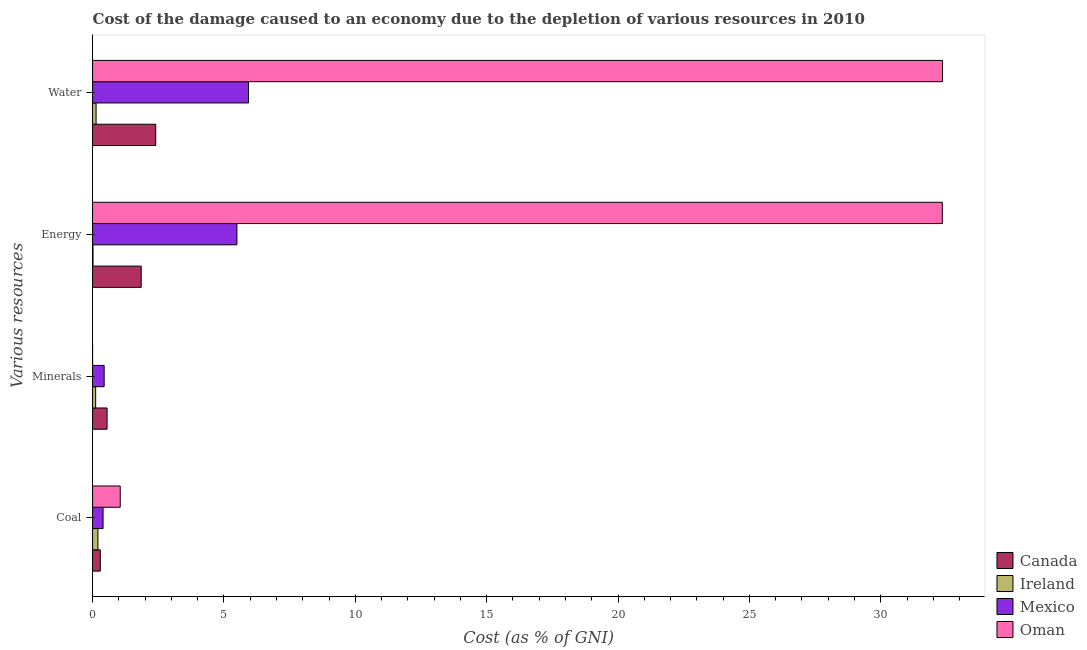How many different coloured bars are there?
Provide a succinct answer. 4. How many bars are there on the 4th tick from the bottom?
Offer a very short reply. 4. What is the label of the 3rd group of bars from the top?
Give a very brief answer. Minerals. What is the cost of damage due to depletion of coal in Ireland?
Your answer should be compact. 0.2. Across all countries, what is the maximum cost of damage due to depletion of coal?
Your answer should be very brief. 1.05. Across all countries, what is the minimum cost of damage due to depletion of minerals?
Make the answer very short. 0. In which country was the cost of damage due to depletion of coal maximum?
Provide a short and direct response. Oman. In which country was the cost of damage due to depletion of coal minimum?
Provide a short and direct response. Ireland. What is the total cost of damage due to depletion of minerals in the graph?
Make the answer very short. 1.11. What is the difference between the cost of damage due to depletion of coal in Canada and that in Mexico?
Offer a terse response. -0.1. What is the difference between the cost of damage due to depletion of energy in Oman and the cost of damage due to depletion of minerals in Ireland?
Your answer should be very brief. 32.22. What is the average cost of damage due to depletion of coal per country?
Your response must be concise. 0.49. What is the difference between the cost of damage due to depletion of water and cost of damage due to depletion of minerals in Ireland?
Your answer should be compact. 0.02. What is the ratio of the cost of damage due to depletion of minerals in Ireland to that in Oman?
Your answer should be very brief. 238.04. What is the difference between the highest and the second highest cost of damage due to depletion of water?
Offer a very short reply. 26.41. What is the difference between the highest and the lowest cost of damage due to depletion of minerals?
Your response must be concise. 0.55. In how many countries, is the cost of damage due to depletion of water greater than the average cost of damage due to depletion of water taken over all countries?
Ensure brevity in your answer.  1. Is the sum of the cost of damage due to depletion of coal in Ireland and Canada greater than the maximum cost of damage due to depletion of energy across all countries?
Provide a short and direct response. No. Is it the case that in every country, the sum of the cost of damage due to depletion of coal and cost of damage due to depletion of minerals is greater than the sum of cost of damage due to depletion of water and cost of damage due to depletion of energy?
Your answer should be compact. No. What does the 4th bar from the top in Energy represents?
Provide a short and direct response. Canada. How many countries are there in the graph?
Keep it short and to the point. 4. What is the difference between two consecutive major ticks on the X-axis?
Your response must be concise. 5. Are the values on the major ticks of X-axis written in scientific E-notation?
Keep it short and to the point. No. Does the graph contain any zero values?
Ensure brevity in your answer.  No. Where does the legend appear in the graph?
Your answer should be very brief. Bottom right. What is the title of the graph?
Your answer should be compact. Cost of the damage caused to an economy due to the depletion of various resources in 2010 . What is the label or title of the X-axis?
Provide a succinct answer. Cost (as % of GNI). What is the label or title of the Y-axis?
Make the answer very short. Various resources. What is the Cost (as % of GNI) in Canada in Coal?
Offer a terse response. 0.29. What is the Cost (as % of GNI) of Ireland in Coal?
Give a very brief answer. 0.2. What is the Cost (as % of GNI) in Mexico in Coal?
Keep it short and to the point. 0.4. What is the Cost (as % of GNI) of Oman in Coal?
Keep it short and to the point. 1.05. What is the Cost (as % of GNI) in Canada in Minerals?
Ensure brevity in your answer.  0.55. What is the Cost (as % of GNI) in Ireland in Minerals?
Ensure brevity in your answer.  0.12. What is the Cost (as % of GNI) of Mexico in Minerals?
Make the answer very short. 0.44. What is the Cost (as % of GNI) in Oman in Minerals?
Provide a succinct answer. 0. What is the Cost (as % of GNI) of Canada in Energy?
Your answer should be very brief. 1.85. What is the Cost (as % of GNI) of Ireland in Energy?
Ensure brevity in your answer.  0.02. What is the Cost (as % of GNI) in Mexico in Energy?
Make the answer very short. 5.49. What is the Cost (as % of GNI) of Oman in Energy?
Provide a succinct answer. 32.34. What is the Cost (as % of GNI) of Canada in Water?
Keep it short and to the point. 2.4. What is the Cost (as % of GNI) in Ireland in Water?
Provide a succinct answer. 0.13. What is the Cost (as % of GNI) in Mexico in Water?
Offer a terse response. 5.93. What is the Cost (as % of GNI) in Oman in Water?
Make the answer very short. 32.35. Across all Various resources, what is the maximum Cost (as % of GNI) of Canada?
Make the answer very short. 2.4. Across all Various resources, what is the maximum Cost (as % of GNI) in Ireland?
Provide a succinct answer. 0.2. Across all Various resources, what is the maximum Cost (as % of GNI) of Mexico?
Provide a succinct answer. 5.93. Across all Various resources, what is the maximum Cost (as % of GNI) in Oman?
Your answer should be very brief. 32.35. Across all Various resources, what is the minimum Cost (as % of GNI) of Canada?
Give a very brief answer. 0.29. Across all Various resources, what is the minimum Cost (as % of GNI) in Ireland?
Offer a terse response. 0.02. Across all Various resources, what is the minimum Cost (as % of GNI) of Mexico?
Your answer should be compact. 0.4. Across all Various resources, what is the minimum Cost (as % of GNI) of Oman?
Your answer should be compact. 0. What is the total Cost (as % of GNI) of Canada in the graph?
Ensure brevity in your answer.  5.1. What is the total Cost (as % of GNI) of Ireland in the graph?
Make the answer very short. 0.47. What is the total Cost (as % of GNI) in Mexico in the graph?
Offer a very short reply. 12.27. What is the total Cost (as % of GNI) of Oman in the graph?
Offer a very short reply. 65.74. What is the difference between the Cost (as % of GNI) in Canada in Coal and that in Minerals?
Make the answer very short. -0.26. What is the difference between the Cost (as % of GNI) in Ireland in Coal and that in Minerals?
Your response must be concise. 0.09. What is the difference between the Cost (as % of GNI) of Mexico in Coal and that in Minerals?
Your response must be concise. -0.04. What is the difference between the Cost (as % of GNI) in Oman in Coal and that in Minerals?
Offer a terse response. 1.05. What is the difference between the Cost (as % of GNI) in Canada in Coal and that in Energy?
Offer a terse response. -1.56. What is the difference between the Cost (as % of GNI) in Ireland in Coal and that in Energy?
Offer a terse response. 0.19. What is the difference between the Cost (as % of GNI) in Mexico in Coal and that in Energy?
Ensure brevity in your answer.  -5.09. What is the difference between the Cost (as % of GNI) in Oman in Coal and that in Energy?
Your answer should be very brief. -31.29. What is the difference between the Cost (as % of GNI) of Canada in Coal and that in Water?
Provide a short and direct response. -2.11. What is the difference between the Cost (as % of GNI) in Ireland in Coal and that in Water?
Keep it short and to the point. 0.07. What is the difference between the Cost (as % of GNI) in Mexico in Coal and that in Water?
Your answer should be compact. -5.54. What is the difference between the Cost (as % of GNI) in Oman in Coal and that in Water?
Provide a short and direct response. -31.29. What is the difference between the Cost (as % of GNI) of Canada in Minerals and that in Energy?
Keep it short and to the point. -1.3. What is the difference between the Cost (as % of GNI) of Ireland in Minerals and that in Energy?
Give a very brief answer. 0.1. What is the difference between the Cost (as % of GNI) in Mexico in Minerals and that in Energy?
Provide a succinct answer. -5.05. What is the difference between the Cost (as % of GNI) in Oman in Minerals and that in Energy?
Make the answer very short. -32.34. What is the difference between the Cost (as % of GNI) in Canada in Minerals and that in Water?
Your response must be concise. -1.85. What is the difference between the Cost (as % of GNI) in Ireland in Minerals and that in Water?
Your answer should be compact. -0.02. What is the difference between the Cost (as % of GNI) of Mexico in Minerals and that in Water?
Provide a short and direct response. -5.49. What is the difference between the Cost (as % of GNI) in Oman in Minerals and that in Water?
Give a very brief answer. -32.35. What is the difference between the Cost (as % of GNI) of Canada in Energy and that in Water?
Provide a short and direct response. -0.55. What is the difference between the Cost (as % of GNI) in Ireland in Energy and that in Water?
Make the answer very short. -0.12. What is the difference between the Cost (as % of GNI) of Mexico in Energy and that in Water?
Provide a succinct answer. -0.44. What is the difference between the Cost (as % of GNI) of Oman in Energy and that in Water?
Your response must be concise. -0.01. What is the difference between the Cost (as % of GNI) of Canada in Coal and the Cost (as % of GNI) of Ireland in Minerals?
Your response must be concise. 0.18. What is the difference between the Cost (as % of GNI) in Canada in Coal and the Cost (as % of GNI) in Mexico in Minerals?
Provide a short and direct response. -0.15. What is the difference between the Cost (as % of GNI) of Canada in Coal and the Cost (as % of GNI) of Oman in Minerals?
Offer a very short reply. 0.29. What is the difference between the Cost (as % of GNI) of Ireland in Coal and the Cost (as % of GNI) of Mexico in Minerals?
Offer a terse response. -0.24. What is the difference between the Cost (as % of GNI) in Ireland in Coal and the Cost (as % of GNI) in Oman in Minerals?
Your answer should be very brief. 0.2. What is the difference between the Cost (as % of GNI) in Mexico in Coal and the Cost (as % of GNI) in Oman in Minerals?
Your answer should be compact. 0.4. What is the difference between the Cost (as % of GNI) of Canada in Coal and the Cost (as % of GNI) of Ireland in Energy?
Ensure brevity in your answer.  0.28. What is the difference between the Cost (as % of GNI) in Canada in Coal and the Cost (as % of GNI) in Mexico in Energy?
Give a very brief answer. -5.2. What is the difference between the Cost (as % of GNI) of Canada in Coal and the Cost (as % of GNI) of Oman in Energy?
Provide a short and direct response. -32.05. What is the difference between the Cost (as % of GNI) of Ireland in Coal and the Cost (as % of GNI) of Mexico in Energy?
Ensure brevity in your answer.  -5.29. What is the difference between the Cost (as % of GNI) of Ireland in Coal and the Cost (as % of GNI) of Oman in Energy?
Provide a succinct answer. -32.14. What is the difference between the Cost (as % of GNI) of Mexico in Coal and the Cost (as % of GNI) of Oman in Energy?
Provide a succinct answer. -31.94. What is the difference between the Cost (as % of GNI) in Canada in Coal and the Cost (as % of GNI) in Ireland in Water?
Offer a terse response. 0.16. What is the difference between the Cost (as % of GNI) in Canada in Coal and the Cost (as % of GNI) in Mexico in Water?
Make the answer very short. -5.64. What is the difference between the Cost (as % of GNI) in Canada in Coal and the Cost (as % of GNI) in Oman in Water?
Keep it short and to the point. -32.05. What is the difference between the Cost (as % of GNI) of Ireland in Coal and the Cost (as % of GNI) of Mexico in Water?
Provide a succinct answer. -5.73. What is the difference between the Cost (as % of GNI) of Ireland in Coal and the Cost (as % of GNI) of Oman in Water?
Provide a short and direct response. -32.14. What is the difference between the Cost (as % of GNI) in Mexico in Coal and the Cost (as % of GNI) in Oman in Water?
Provide a succinct answer. -31.95. What is the difference between the Cost (as % of GNI) in Canada in Minerals and the Cost (as % of GNI) in Ireland in Energy?
Make the answer very short. 0.54. What is the difference between the Cost (as % of GNI) in Canada in Minerals and the Cost (as % of GNI) in Mexico in Energy?
Offer a terse response. -4.94. What is the difference between the Cost (as % of GNI) of Canada in Minerals and the Cost (as % of GNI) of Oman in Energy?
Your answer should be compact. -31.79. What is the difference between the Cost (as % of GNI) in Ireland in Minerals and the Cost (as % of GNI) in Mexico in Energy?
Ensure brevity in your answer.  -5.38. What is the difference between the Cost (as % of GNI) in Ireland in Minerals and the Cost (as % of GNI) in Oman in Energy?
Offer a very short reply. -32.22. What is the difference between the Cost (as % of GNI) of Mexico in Minerals and the Cost (as % of GNI) of Oman in Energy?
Your answer should be very brief. -31.9. What is the difference between the Cost (as % of GNI) in Canada in Minerals and the Cost (as % of GNI) in Ireland in Water?
Your answer should be compact. 0.42. What is the difference between the Cost (as % of GNI) in Canada in Minerals and the Cost (as % of GNI) in Mexico in Water?
Offer a terse response. -5.38. What is the difference between the Cost (as % of GNI) of Canada in Minerals and the Cost (as % of GNI) of Oman in Water?
Your answer should be compact. -31.8. What is the difference between the Cost (as % of GNI) of Ireland in Minerals and the Cost (as % of GNI) of Mexico in Water?
Provide a succinct answer. -5.82. What is the difference between the Cost (as % of GNI) of Ireland in Minerals and the Cost (as % of GNI) of Oman in Water?
Keep it short and to the point. -32.23. What is the difference between the Cost (as % of GNI) in Mexico in Minerals and the Cost (as % of GNI) in Oman in Water?
Give a very brief answer. -31.91. What is the difference between the Cost (as % of GNI) in Canada in Energy and the Cost (as % of GNI) in Ireland in Water?
Offer a terse response. 1.72. What is the difference between the Cost (as % of GNI) in Canada in Energy and the Cost (as % of GNI) in Mexico in Water?
Your response must be concise. -4.08. What is the difference between the Cost (as % of GNI) of Canada in Energy and the Cost (as % of GNI) of Oman in Water?
Give a very brief answer. -30.5. What is the difference between the Cost (as % of GNI) of Ireland in Energy and the Cost (as % of GNI) of Mexico in Water?
Offer a very short reply. -5.92. What is the difference between the Cost (as % of GNI) in Ireland in Energy and the Cost (as % of GNI) in Oman in Water?
Keep it short and to the point. -32.33. What is the difference between the Cost (as % of GNI) in Mexico in Energy and the Cost (as % of GNI) in Oman in Water?
Ensure brevity in your answer.  -26.85. What is the average Cost (as % of GNI) in Canada per Various resources?
Give a very brief answer. 1.28. What is the average Cost (as % of GNI) in Ireland per Various resources?
Offer a very short reply. 0.12. What is the average Cost (as % of GNI) in Mexico per Various resources?
Keep it short and to the point. 3.07. What is the average Cost (as % of GNI) in Oman per Various resources?
Provide a succinct answer. 16.44. What is the difference between the Cost (as % of GNI) in Canada and Cost (as % of GNI) in Ireland in Coal?
Your answer should be very brief. 0.09. What is the difference between the Cost (as % of GNI) in Canada and Cost (as % of GNI) in Mexico in Coal?
Offer a terse response. -0.1. What is the difference between the Cost (as % of GNI) of Canada and Cost (as % of GNI) of Oman in Coal?
Offer a very short reply. -0.76. What is the difference between the Cost (as % of GNI) of Ireland and Cost (as % of GNI) of Mexico in Coal?
Your answer should be compact. -0.2. What is the difference between the Cost (as % of GNI) in Ireland and Cost (as % of GNI) in Oman in Coal?
Give a very brief answer. -0.85. What is the difference between the Cost (as % of GNI) of Mexico and Cost (as % of GNI) of Oman in Coal?
Offer a terse response. -0.65. What is the difference between the Cost (as % of GNI) of Canada and Cost (as % of GNI) of Ireland in Minerals?
Offer a terse response. 0.43. What is the difference between the Cost (as % of GNI) of Canada and Cost (as % of GNI) of Mexico in Minerals?
Your answer should be compact. 0.11. What is the difference between the Cost (as % of GNI) in Canada and Cost (as % of GNI) in Oman in Minerals?
Make the answer very short. 0.55. What is the difference between the Cost (as % of GNI) of Ireland and Cost (as % of GNI) of Mexico in Minerals?
Offer a very short reply. -0.32. What is the difference between the Cost (as % of GNI) of Ireland and Cost (as % of GNI) of Oman in Minerals?
Ensure brevity in your answer.  0.12. What is the difference between the Cost (as % of GNI) in Mexico and Cost (as % of GNI) in Oman in Minerals?
Keep it short and to the point. 0.44. What is the difference between the Cost (as % of GNI) in Canada and Cost (as % of GNI) in Ireland in Energy?
Offer a terse response. 1.83. What is the difference between the Cost (as % of GNI) of Canada and Cost (as % of GNI) of Mexico in Energy?
Give a very brief answer. -3.64. What is the difference between the Cost (as % of GNI) in Canada and Cost (as % of GNI) in Oman in Energy?
Ensure brevity in your answer.  -30.49. What is the difference between the Cost (as % of GNI) of Ireland and Cost (as % of GNI) of Mexico in Energy?
Make the answer very short. -5.48. What is the difference between the Cost (as % of GNI) of Ireland and Cost (as % of GNI) of Oman in Energy?
Your response must be concise. -32.33. What is the difference between the Cost (as % of GNI) of Mexico and Cost (as % of GNI) of Oman in Energy?
Provide a short and direct response. -26.85. What is the difference between the Cost (as % of GNI) in Canada and Cost (as % of GNI) in Ireland in Water?
Your response must be concise. 2.27. What is the difference between the Cost (as % of GNI) of Canada and Cost (as % of GNI) of Mexico in Water?
Offer a terse response. -3.53. What is the difference between the Cost (as % of GNI) of Canada and Cost (as % of GNI) of Oman in Water?
Offer a terse response. -29.94. What is the difference between the Cost (as % of GNI) of Ireland and Cost (as % of GNI) of Mexico in Water?
Make the answer very short. -5.8. What is the difference between the Cost (as % of GNI) of Ireland and Cost (as % of GNI) of Oman in Water?
Keep it short and to the point. -32.21. What is the difference between the Cost (as % of GNI) of Mexico and Cost (as % of GNI) of Oman in Water?
Offer a very short reply. -26.41. What is the ratio of the Cost (as % of GNI) in Canada in Coal to that in Minerals?
Your answer should be compact. 0.53. What is the ratio of the Cost (as % of GNI) of Ireland in Coal to that in Minerals?
Keep it short and to the point. 1.74. What is the ratio of the Cost (as % of GNI) in Mexico in Coal to that in Minerals?
Your answer should be compact. 0.91. What is the ratio of the Cost (as % of GNI) in Oman in Coal to that in Minerals?
Provide a succinct answer. 2134.44. What is the ratio of the Cost (as % of GNI) in Canada in Coal to that in Energy?
Provide a short and direct response. 0.16. What is the ratio of the Cost (as % of GNI) of Ireland in Coal to that in Energy?
Offer a terse response. 12.44. What is the ratio of the Cost (as % of GNI) in Mexico in Coal to that in Energy?
Give a very brief answer. 0.07. What is the ratio of the Cost (as % of GNI) in Oman in Coal to that in Energy?
Offer a very short reply. 0.03. What is the ratio of the Cost (as % of GNI) of Canada in Coal to that in Water?
Keep it short and to the point. 0.12. What is the ratio of the Cost (as % of GNI) of Ireland in Coal to that in Water?
Your answer should be very brief. 1.52. What is the ratio of the Cost (as % of GNI) of Mexico in Coal to that in Water?
Offer a terse response. 0.07. What is the ratio of the Cost (as % of GNI) in Oman in Coal to that in Water?
Give a very brief answer. 0.03. What is the ratio of the Cost (as % of GNI) of Canada in Minerals to that in Energy?
Keep it short and to the point. 0.3. What is the ratio of the Cost (as % of GNI) of Ireland in Minerals to that in Energy?
Offer a very short reply. 7.16. What is the ratio of the Cost (as % of GNI) of Mexico in Minerals to that in Energy?
Provide a succinct answer. 0.08. What is the ratio of the Cost (as % of GNI) of Oman in Minerals to that in Energy?
Offer a very short reply. 0. What is the ratio of the Cost (as % of GNI) in Canada in Minerals to that in Water?
Your answer should be compact. 0.23. What is the ratio of the Cost (as % of GNI) of Ireland in Minerals to that in Water?
Offer a very short reply. 0.88. What is the ratio of the Cost (as % of GNI) in Mexico in Minerals to that in Water?
Make the answer very short. 0.07. What is the ratio of the Cost (as % of GNI) of Canada in Energy to that in Water?
Provide a short and direct response. 0.77. What is the ratio of the Cost (as % of GNI) in Ireland in Energy to that in Water?
Offer a very short reply. 0.12. What is the ratio of the Cost (as % of GNI) in Mexico in Energy to that in Water?
Offer a very short reply. 0.93. What is the ratio of the Cost (as % of GNI) in Oman in Energy to that in Water?
Your answer should be very brief. 1. What is the difference between the highest and the second highest Cost (as % of GNI) of Canada?
Keep it short and to the point. 0.55. What is the difference between the highest and the second highest Cost (as % of GNI) in Ireland?
Ensure brevity in your answer.  0.07. What is the difference between the highest and the second highest Cost (as % of GNI) of Mexico?
Your answer should be compact. 0.44. What is the difference between the highest and the second highest Cost (as % of GNI) in Oman?
Your response must be concise. 0.01. What is the difference between the highest and the lowest Cost (as % of GNI) in Canada?
Your response must be concise. 2.11. What is the difference between the highest and the lowest Cost (as % of GNI) in Ireland?
Provide a short and direct response. 0.19. What is the difference between the highest and the lowest Cost (as % of GNI) of Mexico?
Make the answer very short. 5.54. What is the difference between the highest and the lowest Cost (as % of GNI) in Oman?
Give a very brief answer. 32.35. 